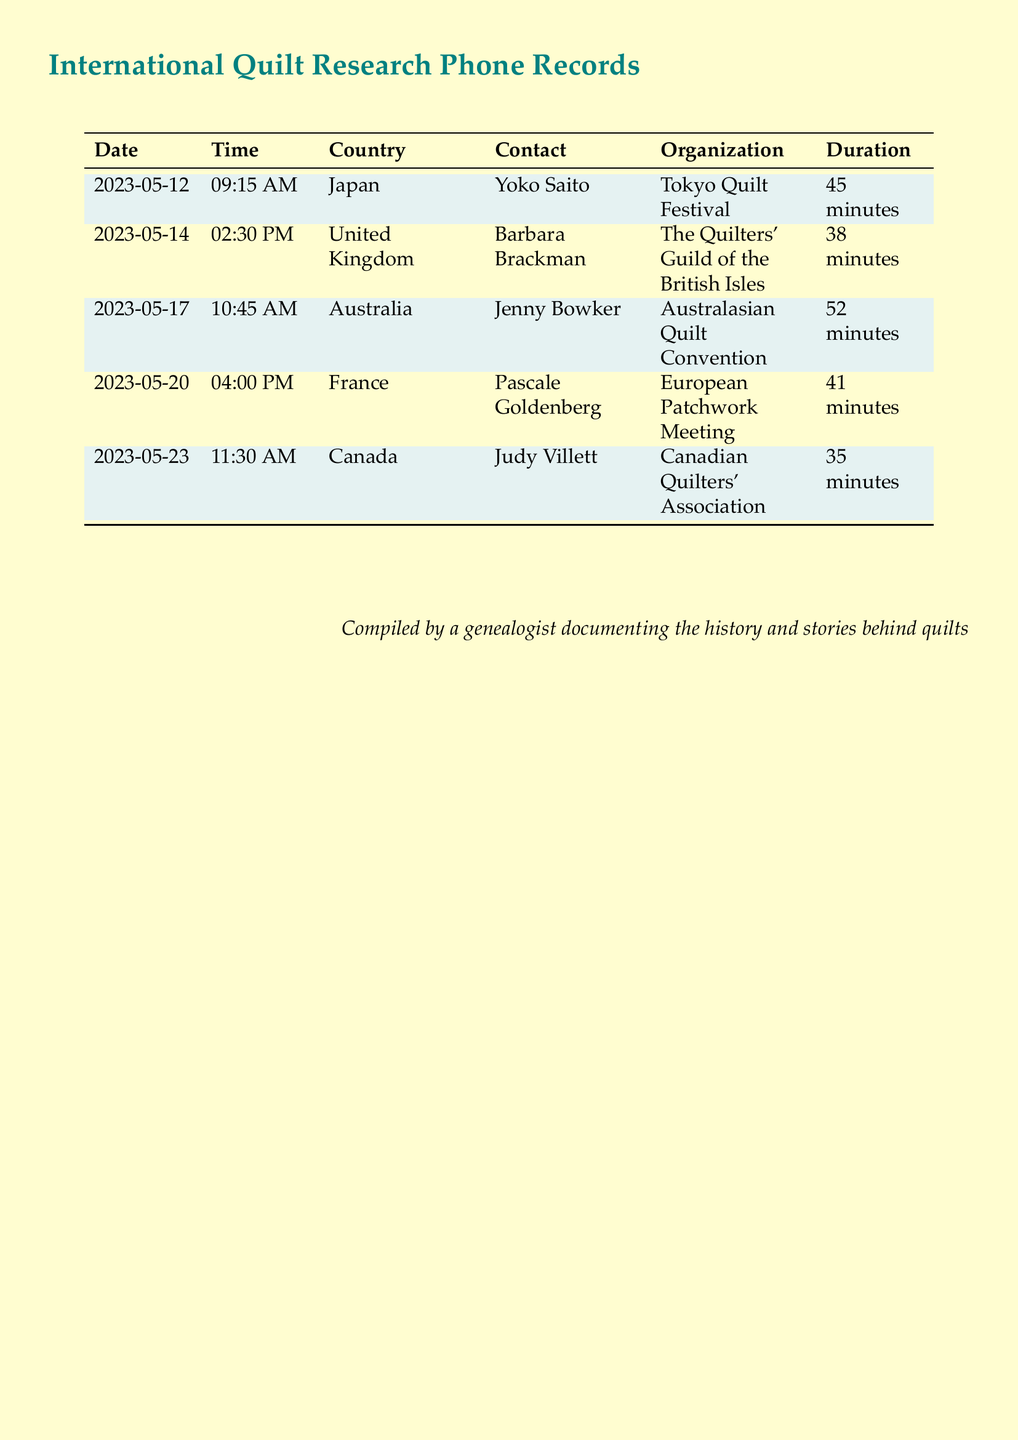What is the date of the call to Japan? The date of the call to Japan is mentioned clearly in the table as 2023-05-12.
Answer: 2023-05-12 Who was the contact in the United Kingdom? The document lists Barbara Brackman as the contact for the United Kingdom.
Answer: Barbara Brackman What is the duration of the call to France? The duration for the call to France is recorded in the table; it is 41 minutes.
Answer: 41 minutes Which organization is associated with Jenny Bowker in Australia? The organization associated with Jenny Bowker is the Australasian Quilt Convention.
Answer: Australasian Quilt Convention What is the total number of international calls listed in the document? The document provides a total of five distinct calls listed in the table.
Answer: 5 Which country had a phone call at 11:30 AM on May 23, 2023? The country associated with this time and date is Canada according to the records.
Answer: Canada What is the contact's name for the call made to Japan? The contact's name for the call made to Japan is Yoko Saito.
Answer: Yoko Saito How long was the shortest call listed in the document? The shortest call is 35 minutes, as stated for the call to Canada.
Answer: 35 minutes 